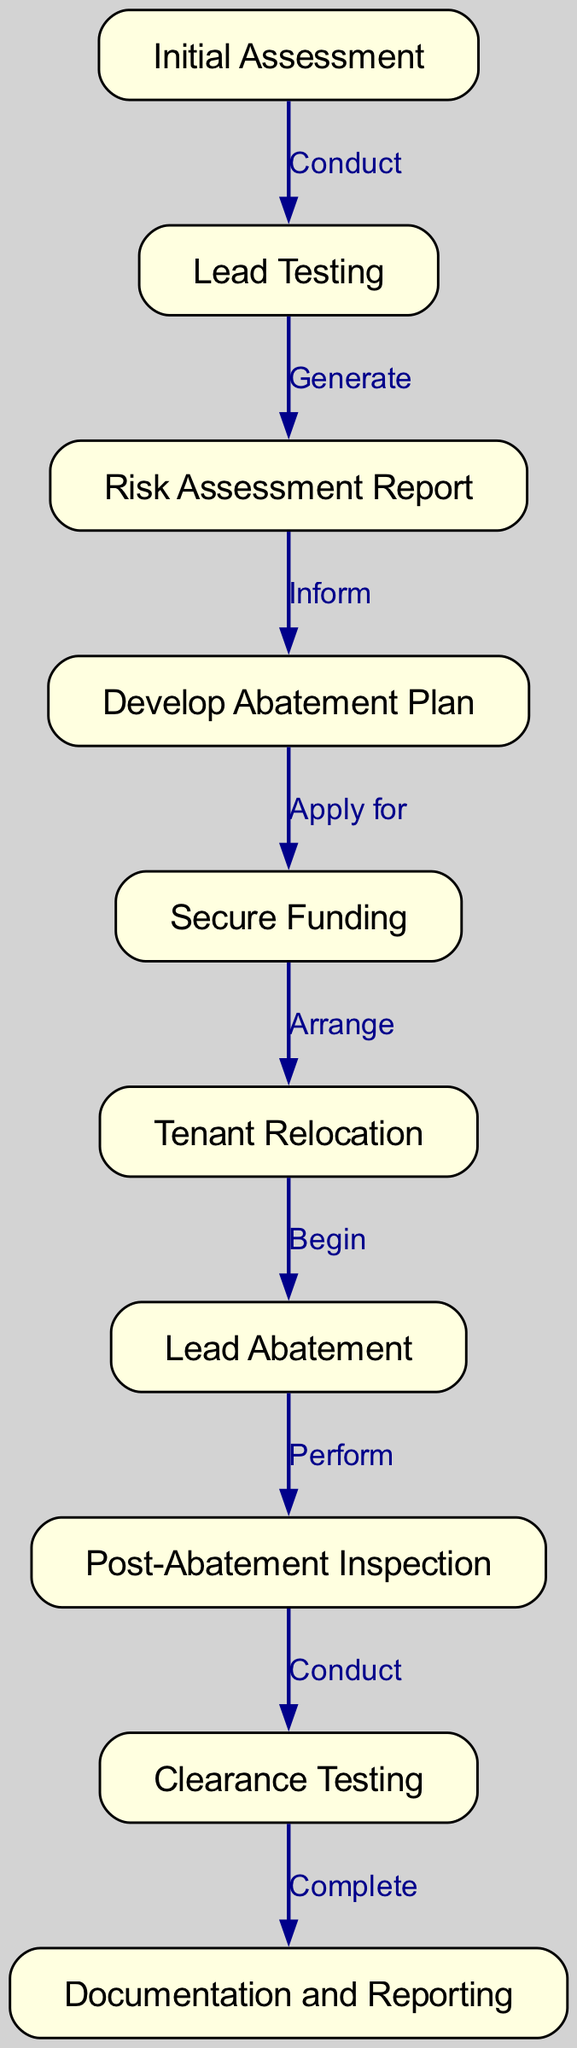What is the first step in the lead abatement process? The diagram starts with the "Initial Assessment" as the first node, which indicates the very beginning of the lead abatement process.
Answer: Initial Assessment How many nodes are in the diagram? To find the number of nodes, count the unique items listed under "nodes" in the provided data. There are ten nodes in total.
Answer: 10 What action is taken after "Lead Testing"? The diagram indicates that after "Lead Testing," the next action is to "Generate" a "Risk Assessment Report."
Answer: Generate Which stage follows "Tenant Relocation"? Based on the sequence in the diagram, the stage that follows "Tenant Relocation" is "Lead Abatement."
Answer: Lead Abatement What document is produced after the "Risk Assessment Report"? After the "Risk Assessment Report," the diagram shows that the next step involves "Develop Abatement Plan."
Answer: Develop Abatement Plan What is the last step in the lead abatement process? The last node in the diagram indicates that the final step in the lead abatement process is "Documentation and Reporting."
Answer: Documentation and Reporting What action must be taken right before "Lead Abatement"? The diagram illustrates that "Tenant Relocation" is needed before "Lead Abatement" can begin, indicating a necessary preparatory action.
Answer: Tenant Relocation During which step is funding secured? The diagram shows that the action to "Secure Funding" occurs after the "Develop Abatement Plan," linking the planning to the financial aspect.
Answer: Secure Funding How does "Lead Testing" relate to "Risk Assessment Report"? The relationship is that "Lead Testing" directly leads to the generation of a "Risk Assessment Report," indicating that testing is a precursor to the report.
Answer: Generate 